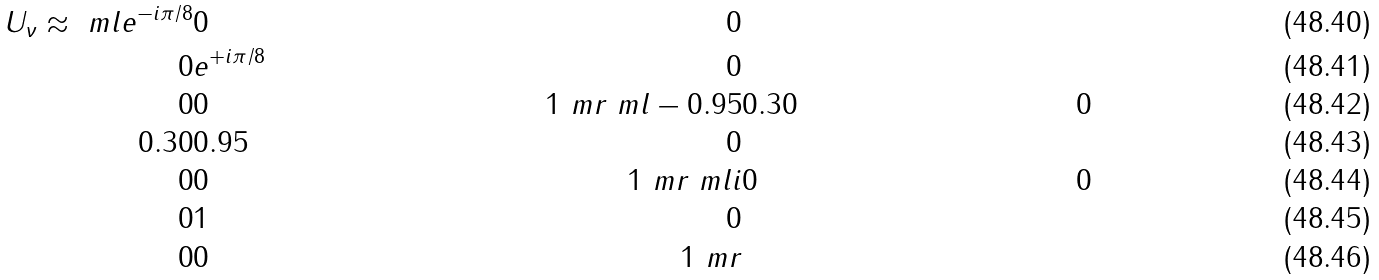<formula> <loc_0><loc_0><loc_500><loc_500>U _ { \nu } \approx \ m l e ^ { - i \pi / 8 } & 0 & 0 \\ 0 & e ^ { + i \pi / 8 } & 0 \\ 0 & 0 & 1 \ m r \ m l - 0 . 9 5 & 0 . 3 0 & 0 \\ 0 . 3 0 & 0 . 9 5 & 0 \\ 0 & 0 & 1 \ m r \ m l i & 0 & 0 \\ 0 & 1 & 0 \\ 0 & 0 & 1 \ m r</formula> 